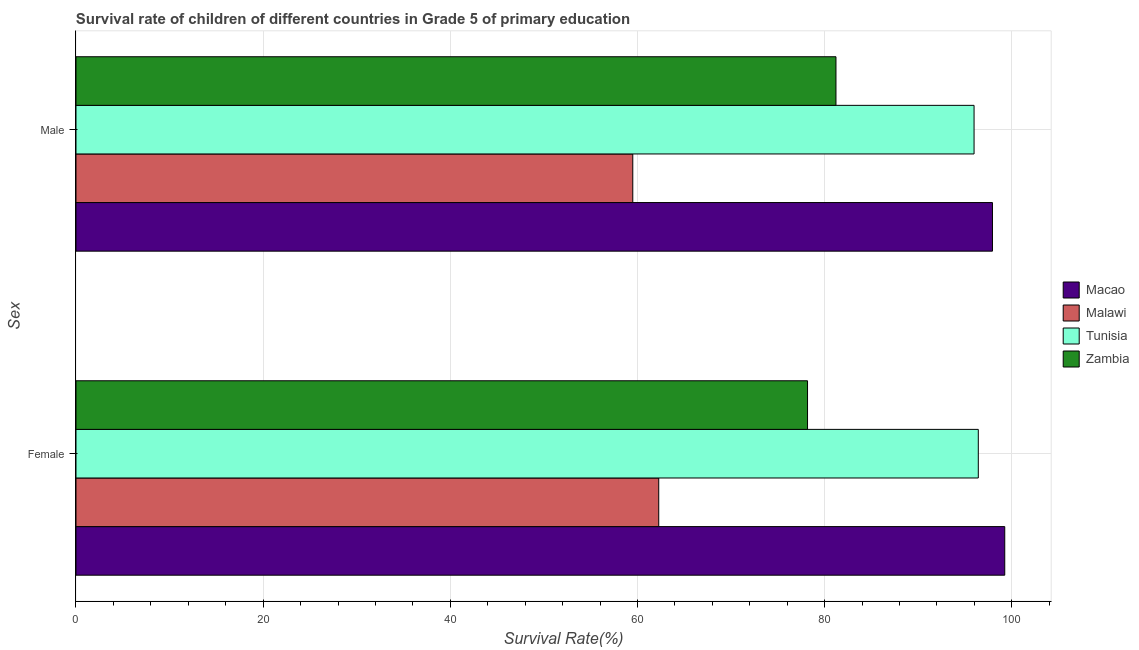Are the number of bars per tick equal to the number of legend labels?
Your answer should be compact. Yes. Are the number of bars on each tick of the Y-axis equal?
Offer a very short reply. Yes. How many bars are there on the 2nd tick from the bottom?
Your answer should be very brief. 4. What is the survival rate of male students in primary education in Malawi?
Offer a very short reply. 59.5. Across all countries, what is the maximum survival rate of male students in primary education?
Keep it short and to the point. 97.94. Across all countries, what is the minimum survival rate of female students in primary education?
Offer a terse response. 62.27. In which country was the survival rate of male students in primary education maximum?
Your answer should be compact. Macao. In which country was the survival rate of male students in primary education minimum?
Offer a terse response. Malawi. What is the total survival rate of female students in primary education in the graph?
Your answer should be very brief. 336.12. What is the difference between the survival rate of male students in primary education in Zambia and that in Macao?
Provide a succinct answer. -16.72. What is the difference between the survival rate of male students in primary education in Zambia and the survival rate of female students in primary education in Tunisia?
Your answer should be compact. -15.21. What is the average survival rate of male students in primary education per country?
Provide a succinct answer. 83.66. What is the difference between the survival rate of female students in primary education and survival rate of male students in primary education in Macao?
Make the answer very short. 1.31. What is the ratio of the survival rate of male students in primary education in Macao to that in Zambia?
Your response must be concise. 1.21. Is the survival rate of female students in primary education in Tunisia less than that in Zambia?
Ensure brevity in your answer.  No. What does the 1st bar from the top in Female represents?
Offer a terse response. Zambia. What does the 1st bar from the bottom in Male represents?
Your answer should be very brief. Macao. How many bars are there?
Your answer should be compact. 8. Are all the bars in the graph horizontal?
Offer a very short reply. Yes. How many countries are there in the graph?
Give a very brief answer. 4. What is the difference between two consecutive major ticks on the X-axis?
Offer a very short reply. 20. Are the values on the major ticks of X-axis written in scientific E-notation?
Your answer should be compact. No. How are the legend labels stacked?
Give a very brief answer. Vertical. What is the title of the graph?
Offer a very short reply. Survival rate of children of different countries in Grade 5 of primary education. What is the label or title of the X-axis?
Your answer should be compact. Survival Rate(%). What is the label or title of the Y-axis?
Make the answer very short. Sex. What is the Survival Rate(%) in Macao in Female?
Make the answer very short. 99.25. What is the Survival Rate(%) in Malawi in Female?
Make the answer very short. 62.27. What is the Survival Rate(%) in Tunisia in Female?
Your response must be concise. 96.42. What is the Survival Rate(%) of Zambia in Female?
Offer a terse response. 78.18. What is the Survival Rate(%) in Macao in Male?
Ensure brevity in your answer.  97.94. What is the Survival Rate(%) of Malawi in Male?
Make the answer very short. 59.5. What is the Survival Rate(%) of Tunisia in Male?
Offer a very short reply. 95.97. What is the Survival Rate(%) of Zambia in Male?
Provide a succinct answer. 81.21. Across all Sex, what is the maximum Survival Rate(%) in Macao?
Make the answer very short. 99.25. Across all Sex, what is the maximum Survival Rate(%) in Malawi?
Provide a succinct answer. 62.27. Across all Sex, what is the maximum Survival Rate(%) in Tunisia?
Provide a succinct answer. 96.42. Across all Sex, what is the maximum Survival Rate(%) in Zambia?
Your answer should be very brief. 81.21. Across all Sex, what is the minimum Survival Rate(%) of Macao?
Your answer should be very brief. 97.94. Across all Sex, what is the minimum Survival Rate(%) of Malawi?
Your answer should be compact. 59.5. Across all Sex, what is the minimum Survival Rate(%) of Tunisia?
Ensure brevity in your answer.  95.97. Across all Sex, what is the minimum Survival Rate(%) of Zambia?
Provide a short and direct response. 78.18. What is the total Survival Rate(%) of Macao in the graph?
Keep it short and to the point. 197.19. What is the total Survival Rate(%) of Malawi in the graph?
Your answer should be compact. 121.77. What is the total Survival Rate(%) of Tunisia in the graph?
Give a very brief answer. 192.39. What is the total Survival Rate(%) of Zambia in the graph?
Your answer should be compact. 159.39. What is the difference between the Survival Rate(%) in Macao in Female and that in Male?
Give a very brief answer. 1.31. What is the difference between the Survival Rate(%) of Malawi in Female and that in Male?
Keep it short and to the point. 2.77. What is the difference between the Survival Rate(%) in Tunisia in Female and that in Male?
Offer a very short reply. 0.45. What is the difference between the Survival Rate(%) in Zambia in Female and that in Male?
Provide a succinct answer. -3.04. What is the difference between the Survival Rate(%) of Macao in Female and the Survival Rate(%) of Malawi in Male?
Your response must be concise. 39.75. What is the difference between the Survival Rate(%) in Macao in Female and the Survival Rate(%) in Tunisia in Male?
Offer a terse response. 3.28. What is the difference between the Survival Rate(%) of Macao in Female and the Survival Rate(%) of Zambia in Male?
Your answer should be very brief. 18.04. What is the difference between the Survival Rate(%) of Malawi in Female and the Survival Rate(%) of Tunisia in Male?
Offer a very short reply. -33.7. What is the difference between the Survival Rate(%) in Malawi in Female and the Survival Rate(%) in Zambia in Male?
Provide a succinct answer. -18.94. What is the difference between the Survival Rate(%) in Tunisia in Female and the Survival Rate(%) in Zambia in Male?
Make the answer very short. 15.21. What is the average Survival Rate(%) of Macao per Sex?
Offer a terse response. 98.59. What is the average Survival Rate(%) of Malawi per Sex?
Provide a succinct answer. 60.89. What is the average Survival Rate(%) in Tunisia per Sex?
Make the answer very short. 96.2. What is the average Survival Rate(%) in Zambia per Sex?
Provide a short and direct response. 79.69. What is the difference between the Survival Rate(%) of Macao and Survival Rate(%) of Malawi in Female?
Your answer should be compact. 36.98. What is the difference between the Survival Rate(%) in Macao and Survival Rate(%) in Tunisia in Female?
Offer a very short reply. 2.83. What is the difference between the Survival Rate(%) of Macao and Survival Rate(%) of Zambia in Female?
Keep it short and to the point. 21.08. What is the difference between the Survival Rate(%) of Malawi and Survival Rate(%) of Tunisia in Female?
Make the answer very short. -34.15. What is the difference between the Survival Rate(%) of Malawi and Survival Rate(%) of Zambia in Female?
Keep it short and to the point. -15.9. What is the difference between the Survival Rate(%) of Tunisia and Survival Rate(%) of Zambia in Female?
Provide a succinct answer. 18.25. What is the difference between the Survival Rate(%) of Macao and Survival Rate(%) of Malawi in Male?
Offer a terse response. 38.44. What is the difference between the Survival Rate(%) of Macao and Survival Rate(%) of Tunisia in Male?
Keep it short and to the point. 1.97. What is the difference between the Survival Rate(%) of Macao and Survival Rate(%) of Zambia in Male?
Ensure brevity in your answer.  16.72. What is the difference between the Survival Rate(%) of Malawi and Survival Rate(%) of Tunisia in Male?
Ensure brevity in your answer.  -36.47. What is the difference between the Survival Rate(%) of Malawi and Survival Rate(%) of Zambia in Male?
Offer a terse response. -21.71. What is the difference between the Survival Rate(%) of Tunisia and Survival Rate(%) of Zambia in Male?
Provide a succinct answer. 14.76. What is the ratio of the Survival Rate(%) of Macao in Female to that in Male?
Make the answer very short. 1.01. What is the ratio of the Survival Rate(%) in Malawi in Female to that in Male?
Offer a very short reply. 1.05. What is the ratio of the Survival Rate(%) of Zambia in Female to that in Male?
Keep it short and to the point. 0.96. What is the difference between the highest and the second highest Survival Rate(%) of Macao?
Give a very brief answer. 1.31. What is the difference between the highest and the second highest Survival Rate(%) in Malawi?
Give a very brief answer. 2.77. What is the difference between the highest and the second highest Survival Rate(%) in Tunisia?
Make the answer very short. 0.45. What is the difference between the highest and the second highest Survival Rate(%) in Zambia?
Ensure brevity in your answer.  3.04. What is the difference between the highest and the lowest Survival Rate(%) in Macao?
Offer a very short reply. 1.31. What is the difference between the highest and the lowest Survival Rate(%) in Malawi?
Your answer should be very brief. 2.77. What is the difference between the highest and the lowest Survival Rate(%) of Tunisia?
Offer a very short reply. 0.45. What is the difference between the highest and the lowest Survival Rate(%) in Zambia?
Provide a succinct answer. 3.04. 